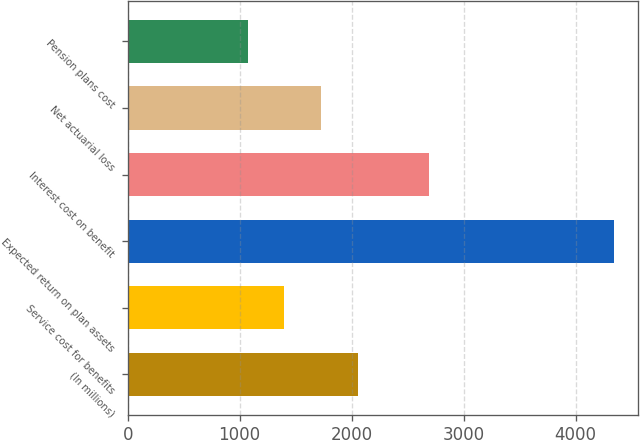<chart> <loc_0><loc_0><loc_500><loc_500><bar_chart><fcel>(In millions)<fcel>Service cost for benefits<fcel>Expected return on plan assets<fcel>Interest cost on benefit<fcel>Net actuarial loss<fcel>Pension plans cost<nl><fcel>2053.6<fcel>1399.2<fcel>4344<fcel>2693<fcel>1726.4<fcel>1072<nl></chart> 